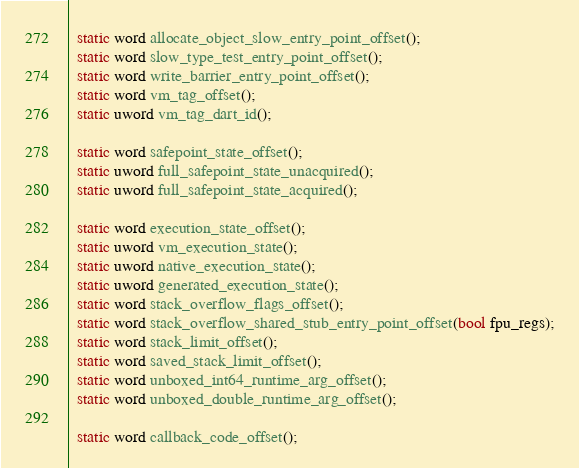Convert code to text. <code><loc_0><loc_0><loc_500><loc_500><_C_>  static word allocate_object_slow_entry_point_offset();
  static word slow_type_test_entry_point_offset();
  static word write_barrier_entry_point_offset();
  static word vm_tag_offset();
  static uword vm_tag_dart_id();

  static word safepoint_state_offset();
  static uword full_safepoint_state_unacquired();
  static uword full_safepoint_state_acquired();

  static word execution_state_offset();
  static uword vm_execution_state();
  static uword native_execution_state();
  static uword generated_execution_state();
  static word stack_overflow_flags_offset();
  static word stack_overflow_shared_stub_entry_point_offset(bool fpu_regs);
  static word stack_limit_offset();
  static word saved_stack_limit_offset();
  static word unboxed_int64_runtime_arg_offset();
  static word unboxed_double_runtime_arg_offset();

  static word callback_code_offset();</code> 